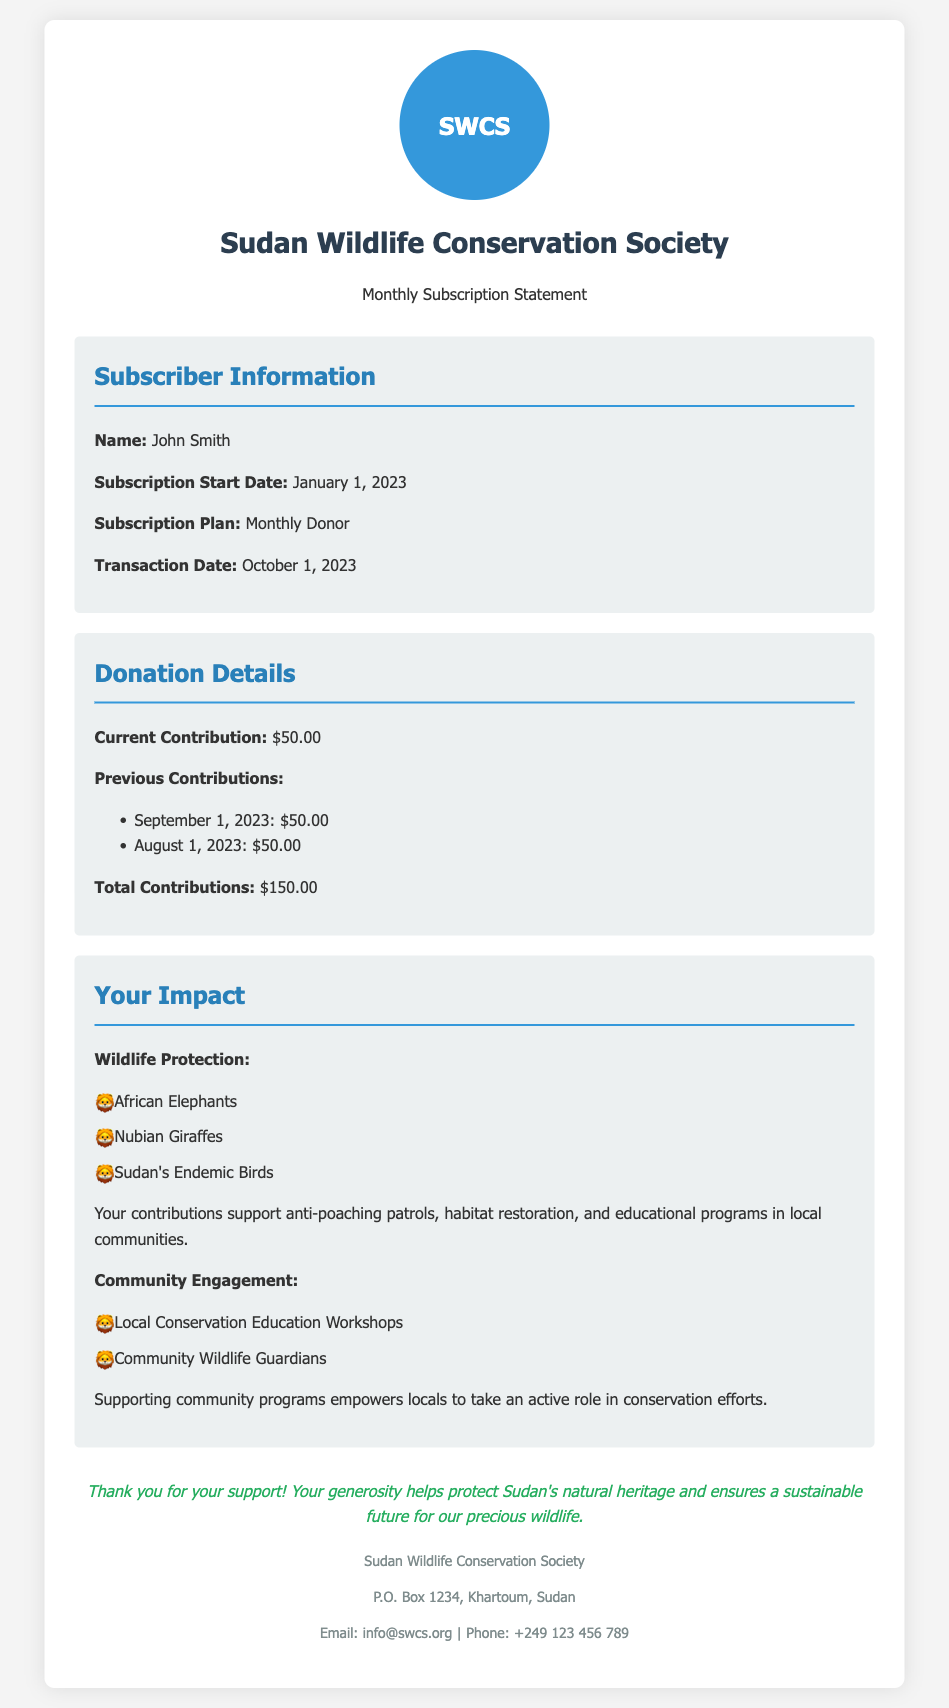What is the subscriber's name? The subscriber's name is explicitly mentioned in the document.
Answer: John Smith What is the current contribution amount? The current contribution amount is clearly stated in the donation details section.
Answer: $50.00 What was the transaction date? The transaction date is listed with the subscriber information.
Answer: October 1, 2023 How many total contributions have been made? The document summarizes the total contributions across all months.
Answer: $150.00 Which wildlife species does the donation help protect? The impact section lists the specific wildlife that benefits from contributions.
Answer: African Elephants, Nubian Giraffes, Sudan's Endemic Birds What type of subscription plan does the subscriber have? The subscription plan is mentioned in the subscriber information.
Answer: Monthly Donor What kind of community programs are supported by the contributions? The document provides details about community engagement programs.
Answer: Local Conservation Education Workshops, Community Wildlife Guardians What is the purpose of the contributions mentioned in the document? The purpose is described in the impact information section regarding conservation efforts.
Answer: Support anti-poaching patrols, habitat restoration, and educational programs What is the organization’s email address? The organization's contact email is provided in the document.
Answer: info@swcs.org 